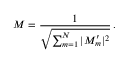<formula> <loc_0><loc_0><loc_500><loc_500>M = \frac { 1 } { \sqrt { \sum _ { m = 1 } ^ { N } | M _ { m } ^ { \prime } | ^ { 2 } } } \, .</formula> 